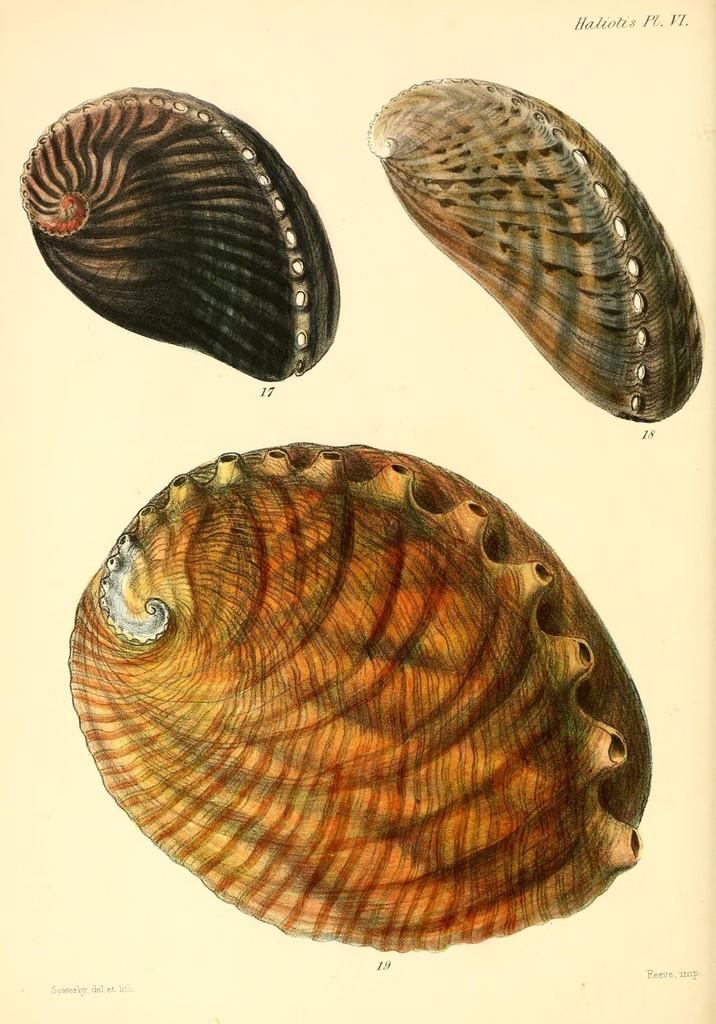What types of content are present on the paper in the image? There are words, numbers, and pictures of seashells on the paper. Can you describe the nature of the words on the paper? Unfortunately, the specific nature of the words cannot be determined from the image alone. What is the purpose of the numbers on the paper? The purpose of the numbers on the paper cannot be determined from the image alone. How many legs can be seen on the spoon in the image? There is no spoon present in the image, so it is not possible to determine the number of legs on a spoon. 